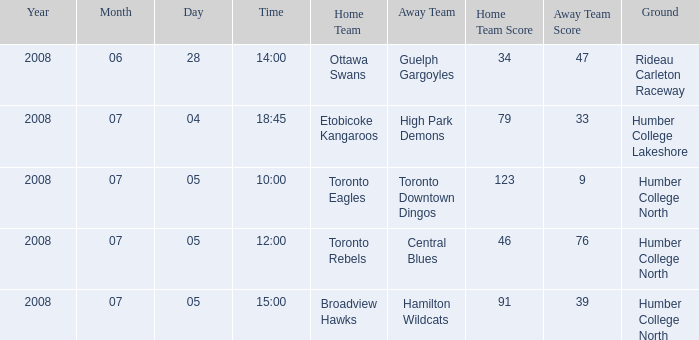What is the Ground with an Away that is central blues? Humber College North. 